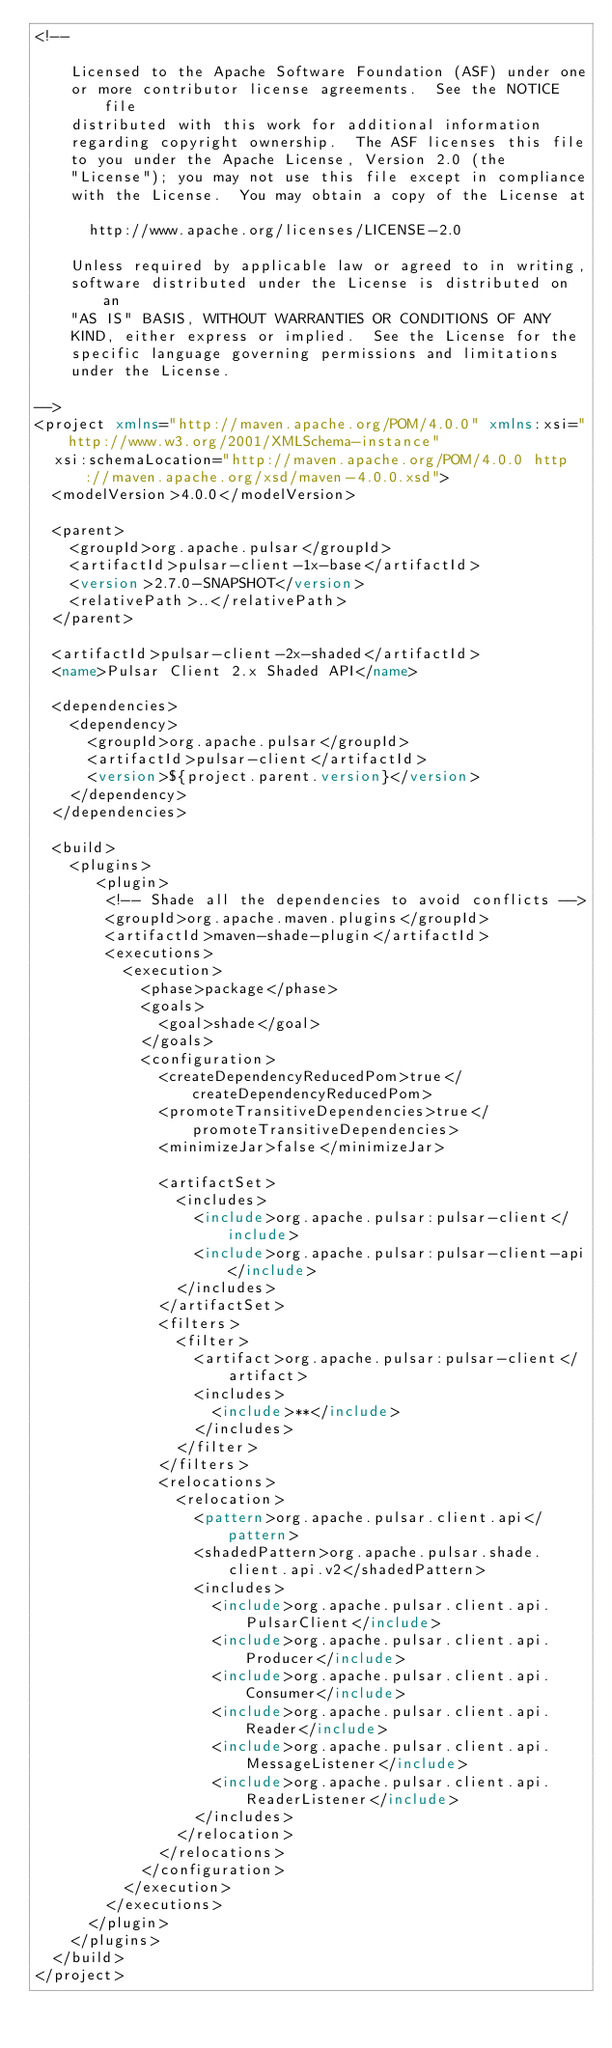<code> <loc_0><loc_0><loc_500><loc_500><_XML_><!--

    Licensed to the Apache Software Foundation (ASF) under one
    or more contributor license agreements.  See the NOTICE file
    distributed with this work for additional information
    regarding copyright ownership.  The ASF licenses this file
    to you under the Apache License, Version 2.0 (the
    "License"); you may not use this file except in compliance
    with the License.  You may obtain a copy of the License at

      http://www.apache.org/licenses/LICENSE-2.0

    Unless required by applicable law or agreed to in writing,
    software distributed under the License is distributed on an
    "AS IS" BASIS, WITHOUT WARRANTIES OR CONDITIONS OF ANY
    KIND, either express or implied.  See the License for the
    specific language governing permissions and limitations
    under the License.

-->
<project xmlns="http://maven.apache.org/POM/4.0.0" xmlns:xsi="http://www.w3.org/2001/XMLSchema-instance"
  xsi:schemaLocation="http://maven.apache.org/POM/4.0.0 http://maven.apache.org/xsd/maven-4.0.0.xsd">
  <modelVersion>4.0.0</modelVersion>

  <parent>
    <groupId>org.apache.pulsar</groupId>
    <artifactId>pulsar-client-1x-base</artifactId>
    <version>2.7.0-SNAPSHOT</version>
    <relativePath>..</relativePath>
  </parent>

  <artifactId>pulsar-client-2x-shaded</artifactId>
  <name>Pulsar Client 2.x Shaded API</name>

  <dependencies>
    <dependency>
      <groupId>org.apache.pulsar</groupId>
      <artifactId>pulsar-client</artifactId>
      <version>${project.parent.version}</version>
    </dependency>
  </dependencies>

  <build>
    <plugins>
       <plugin>
        <!-- Shade all the dependencies to avoid conflicts -->
        <groupId>org.apache.maven.plugins</groupId>
        <artifactId>maven-shade-plugin</artifactId>
        <executions>
          <execution>
            <phase>package</phase>
            <goals>
              <goal>shade</goal>
            </goals>
            <configuration>
              <createDependencyReducedPom>true</createDependencyReducedPom>
              <promoteTransitiveDependencies>true</promoteTransitiveDependencies>
              <minimizeJar>false</minimizeJar>

              <artifactSet>
                <includes>
                  <include>org.apache.pulsar:pulsar-client</include>
                  <include>org.apache.pulsar:pulsar-client-api</include>
                </includes>
              </artifactSet>
              <filters>
                <filter>
                  <artifact>org.apache.pulsar:pulsar-client</artifact>
                  <includes>
                    <include>**</include>
                  </includes>
                </filter>
              </filters>
              <relocations>
                <relocation>
                  <pattern>org.apache.pulsar.client.api</pattern>
                  <shadedPattern>org.apache.pulsar.shade.client.api.v2</shadedPattern>
                  <includes>
                    <include>org.apache.pulsar.client.api.PulsarClient</include>
                    <include>org.apache.pulsar.client.api.Producer</include>
                    <include>org.apache.pulsar.client.api.Consumer</include>
                    <include>org.apache.pulsar.client.api.Reader</include>
                    <include>org.apache.pulsar.client.api.MessageListener</include>
                    <include>org.apache.pulsar.client.api.ReaderListener</include>
                  </includes>
                </relocation>
              </relocations>
            </configuration>
          </execution>
        </executions>
      </plugin>
    </plugins>
  </build>
</project>
</code> 